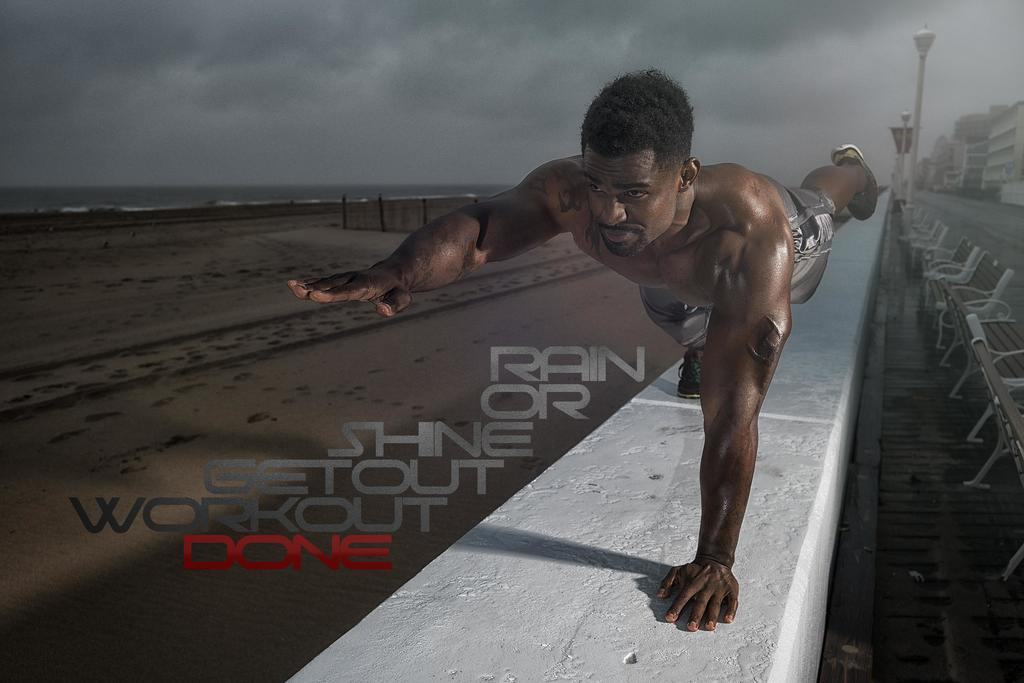What is depicted on the wall in the image? There is a man on the wall in the image. What else can be seen in the image besides the man on the wall? There is text, water, buildings, benches on the sidewalk, and pole lights visible in the image. What is the condition of the sky in the image? The sky is cloudy in the image. What type of toys can be seen in the hands of the manager in the image? There is no manager or toys present in the image. 